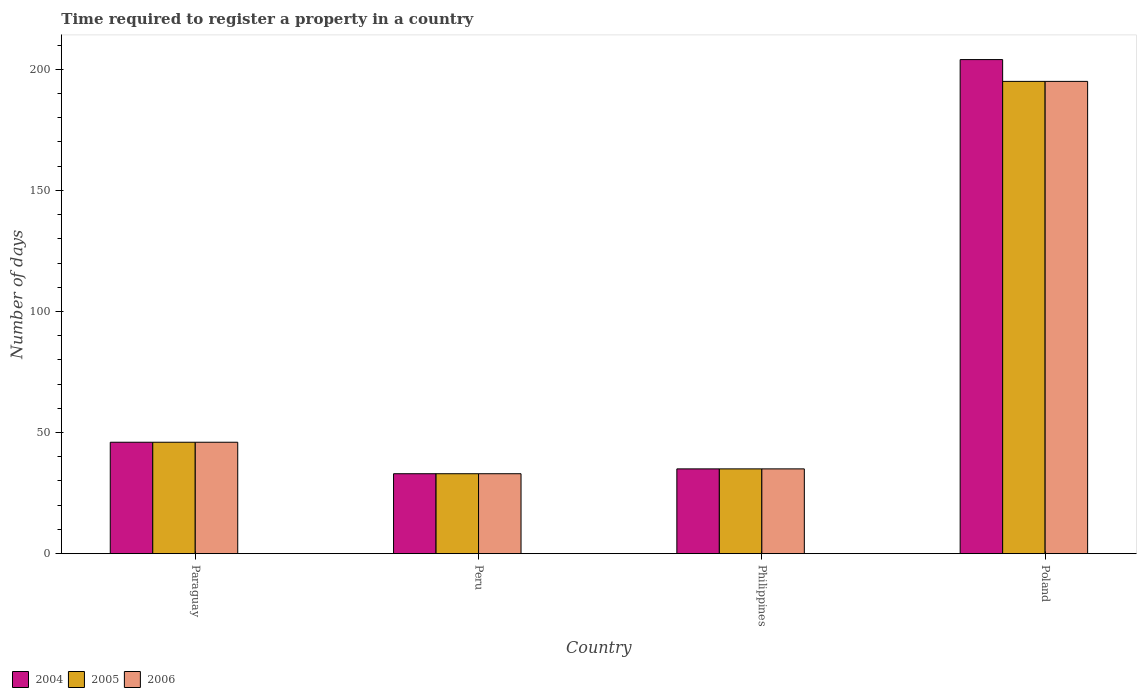How many different coloured bars are there?
Make the answer very short. 3. Are the number of bars per tick equal to the number of legend labels?
Offer a very short reply. Yes. Are the number of bars on each tick of the X-axis equal?
Keep it short and to the point. Yes. What is the number of days required to register a property in 2004 in Paraguay?
Your answer should be compact. 46. Across all countries, what is the maximum number of days required to register a property in 2005?
Your answer should be very brief. 195. In which country was the number of days required to register a property in 2006 minimum?
Make the answer very short. Peru. What is the total number of days required to register a property in 2005 in the graph?
Offer a terse response. 309. What is the difference between the number of days required to register a property in 2006 in Peru and that in Poland?
Provide a succinct answer. -162. What is the difference between the number of days required to register a property in 2005 in Peru and the number of days required to register a property in 2004 in Paraguay?
Offer a terse response. -13. What is the average number of days required to register a property in 2006 per country?
Your response must be concise. 77.25. What is the difference between the number of days required to register a property of/in 2005 and number of days required to register a property of/in 2006 in Peru?
Your answer should be very brief. 0. What is the ratio of the number of days required to register a property in 2004 in Paraguay to that in Philippines?
Your answer should be very brief. 1.31. Is the number of days required to register a property in 2006 in Paraguay less than that in Poland?
Give a very brief answer. Yes. Is the difference between the number of days required to register a property in 2005 in Paraguay and Peru greater than the difference between the number of days required to register a property in 2006 in Paraguay and Peru?
Provide a succinct answer. No. What is the difference between the highest and the second highest number of days required to register a property in 2006?
Keep it short and to the point. -160. What is the difference between the highest and the lowest number of days required to register a property in 2005?
Offer a very short reply. 162. In how many countries, is the number of days required to register a property in 2004 greater than the average number of days required to register a property in 2004 taken over all countries?
Offer a terse response. 1. Is the sum of the number of days required to register a property in 2006 in Paraguay and Poland greater than the maximum number of days required to register a property in 2005 across all countries?
Ensure brevity in your answer.  Yes. What does the 3rd bar from the right in Peru represents?
Offer a terse response. 2004. How many bars are there?
Your response must be concise. 12. What is the difference between two consecutive major ticks on the Y-axis?
Provide a short and direct response. 50. How are the legend labels stacked?
Ensure brevity in your answer.  Horizontal. What is the title of the graph?
Your response must be concise. Time required to register a property in a country. Does "2012" appear as one of the legend labels in the graph?
Provide a short and direct response. No. What is the label or title of the X-axis?
Provide a short and direct response. Country. What is the label or title of the Y-axis?
Your answer should be very brief. Number of days. What is the Number of days in 2004 in Paraguay?
Your response must be concise. 46. What is the Number of days of 2005 in Paraguay?
Give a very brief answer. 46. What is the Number of days of 2006 in Paraguay?
Give a very brief answer. 46. What is the Number of days of 2006 in Peru?
Give a very brief answer. 33. What is the Number of days in 2004 in Philippines?
Offer a terse response. 35. What is the Number of days of 2005 in Philippines?
Make the answer very short. 35. What is the Number of days of 2004 in Poland?
Provide a short and direct response. 204. What is the Number of days of 2005 in Poland?
Offer a terse response. 195. What is the Number of days of 2006 in Poland?
Ensure brevity in your answer.  195. Across all countries, what is the maximum Number of days in 2004?
Your answer should be compact. 204. Across all countries, what is the maximum Number of days of 2005?
Ensure brevity in your answer.  195. Across all countries, what is the maximum Number of days of 2006?
Ensure brevity in your answer.  195. Across all countries, what is the minimum Number of days in 2004?
Ensure brevity in your answer.  33. Across all countries, what is the minimum Number of days of 2005?
Your answer should be very brief. 33. Across all countries, what is the minimum Number of days in 2006?
Your response must be concise. 33. What is the total Number of days of 2004 in the graph?
Ensure brevity in your answer.  318. What is the total Number of days in 2005 in the graph?
Your answer should be compact. 309. What is the total Number of days of 2006 in the graph?
Your response must be concise. 309. What is the difference between the Number of days in 2004 in Paraguay and that in Peru?
Offer a terse response. 13. What is the difference between the Number of days of 2005 in Paraguay and that in Peru?
Provide a succinct answer. 13. What is the difference between the Number of days of 2004 in Paraguay and that in Poland?
Your answer should be compact. -158. What is the difference between the Number of days in 2005 in Paraguay and that in Poland?
Make the answer very short. -149. What is the difference between the Number of days in 2006 in Paraguay and that in Poland?
Your response must be concise. -149. What is the difference between the Number of days of 2004 in Peru and that in Poland?
Keep it short and to the point. -171. What is the difference between the Number of days in 2005 in Peru and that in Poland?
Make the answer very short. -162. What is the difference between the Number of days of 2006 in Peru and that in Poland?
Provide a succinct answer. -162. What is the difference between the Number of days of 2004 in Philippines and that in Poland?
Your answer should be compact. -169. What is the difference between the Number of days in 2005 in Philippines and that in Poland?
Your response must be concise. -160. What is the difference between the Number of days of 2006 in Philippines and that in Poland?
Provide a succinct answer. -160. What is the difference between the Number of days of 2004 in Paraguay and the Number of days of 2005 in Peru?
Give a very brief answer. 13. What is the difference between the Number of days of 2004 in Paraguay and the Number of days of 2006 in Peru?
Make the answer very short. 13. What is the difference between the Number of days in 2005 in Paraguay and the Number of days in 2006 in Philippines?
Give a very brief answer. 11. What is the difference between the Number of days in 2004 in Paraguay and the Number of days in 2005 in Poland?
Your response must be concise. -149. What is the difference between the Number of days of 2004 in Paraguay and the Number of days of 2006 in Poland?
Provide a succinct answer. -149. What is the difference between the Number of days in 2005 in Paraguay and the Number of days in 2006 in Poland?
Your response must be concise. -149. What is the difference between the Number of days in 2004 in Peru and the Number of days in 2006 in Philippines?
Offer a terse response. -2. What is the difference between the Number of days in 2005 in Peru and the Number of days in 2006 in Philippines?
Offer a very short reply. -2. What is the difference between the Number of days of 2004 in Peru and the Number of days of 2005 in Poland?
Offer a very short reply. -162. What is the difference between the Number of days in 2004 in Peru and the Number of days in 2006 in Poland?
Your answer should be compact. -162. What is the difference between the Number of days in 2005 in Peru and the Number of days in 2006 in Poland?
Give a very brief answer. -162. What is the difference between the Number of days of 2004 in Philippines and the Number of days of 2005 in Poland?
Keep it short and to the point. -160. What is the difference between the Number of days in 2004 in Philippines and the Number of days in 2006 in Poland?
Your answer should be compact. -160. What is the difference between the Number of days in 2005 in Philippines and the Number of days in 2006 in Poland?
Offer a terse response. -160. What is the average Number of days of 2004 per country?
Your answer should be very brief. 79.5. What is the average Number of days of 2005 per country?
Your answer should be compact. 77.25. What is the average Number of days of 2006 per country?
Your answer should be very brief. 77.25. What is the difference between the Number of days of 2005 and Number of days of 2006 in Paraguay?
Provide a succinct answer. 0. What is the difference between the Number of days of 2005 and Number of days of 2006 in Philippines?
Provide a short and direct response. 0. What is the ratio of the Number of days of 2004 in Paraguay to that in Peru?
Your answer should be very brief. 1.39. What is the ratio of the Number of days in 2005 in Paraguay to that in Peru?
Your response must be concise. 1.39. What is the ratio of the Number of days of 2006 in Paraguay to that in Peru?
Your answer should be compact. 1.39. What is the ratio of the Number of days of 2004 in Paraguay to that in Philippines?
Your answer should be compact. 1.31. What is the ratio of the Number of days in 2005 in Paraguay to that in Philippines?
Your answer should be very brief. 1.31. What is the ratio of the Number of days in 2006 in Paraguay to that in Philippines?
Make the answer very short. 1.31. What is the ratio of the Number of days in 2004 in Paraguay to that in Poland?
Ensure brevity in your answer.  0.23. What is the ratio of the Number of days of 2005 in Paraguay to that in Poland?
Your answer should be very brief. 0.24. What is the ratio of the Number of days of 2006 in Paraguay to that in Poland?
Ensure brevity in your answer.  0.24. What is the ratio of the Number of days in 2004 in Peru to that in Philippines?
Your response must be concise. 0.94. What is the ratio of the Number of days in 2005 in Peru to that in Philippines?
Ensure brevity in your answer.  0.94. What is the ratio of the Number of days in 2006 in Peru to that in Philippines?
Offer a very short reply. 0.94. What is the ratio of the Number of days in 2004 in Peru to that in Poland?
Make the answer very short. 0.16. What is the ratio of the Number of days in 2005 in Peru to that in Poland?
Your answer should be very brief. 0.17. What is the ratio of the Number of days of 2006 in Peru to that in Poland?
Provide a succinct answer. 0.17. What is the ratio of the Number of days in 2004 in Philippines to that in Poland?
Offer a very short reply. 0.17. What is the ratio of the Number of days of 2005 in Philippines to that in Poland?
Offer a very short reply. 0.18. What is the ratio of the Number of days in 2006 in Philippines to that in Poland?
Provide a succinct answer. 0.18. What is the difference between the highest and the second highest Number of days of 2004?
Your answer should be very brief. 158. What is the difference between the highest and the second highest Number of days of 2005?
Your answer should be very brief. 149. What is the difference between the highest and the second highest Number of days in 2006?
Your response must be concise. 149. What is the difference between the highest and the lowest Number of days in 2004?
Provide a short and direct response. 171. What is the difference between the highest and the lowest Number of days in 2005?
Offer a very short reply. 162. What is the difference between the highest and the lowest Number of days in 2006?
Your answer should be very brief. 162. 